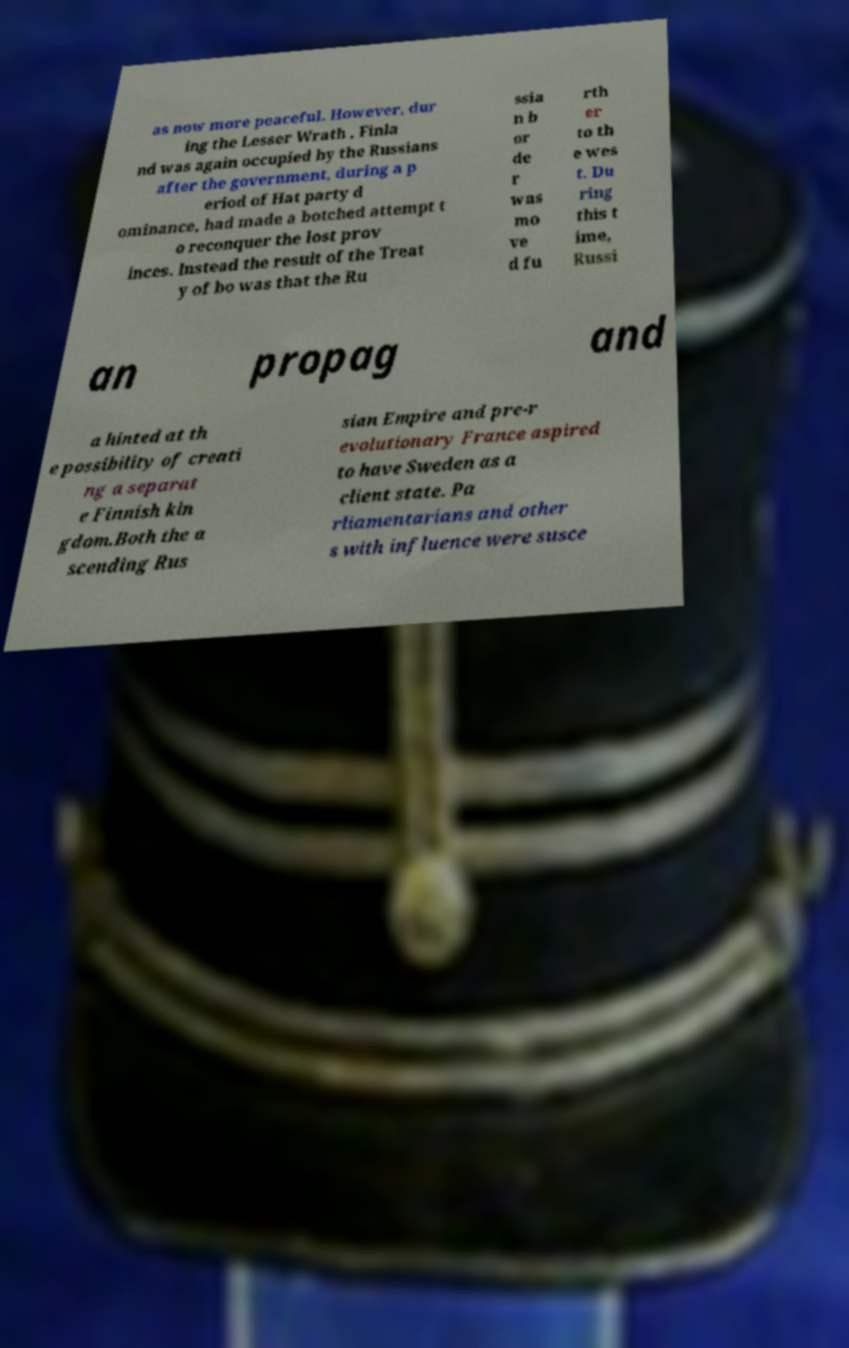I need the written content from this picture converted into text. Can you do that? as now more peaceful. However, dur ing the Lesser Wrath , Finla nd was again occupied by the Russians after the government, during a p eriod of Hat party d ominance, had made a botched attempt t o reconquer the lost prov inces. Instead the result of the Treat y of bo was that the Ru ssia n b or de r was mo ve d fu rth er to th e wes t. Du ring this t ime, Russi an propag and a hinted at th e possibility of creati ng a separat e Finnish kin gdom.Both the a scending Rus sian Empire and pre-r evolutionary France aspired to have Sweden as a client state. Pa rliamentarians and other s with influence were susce 